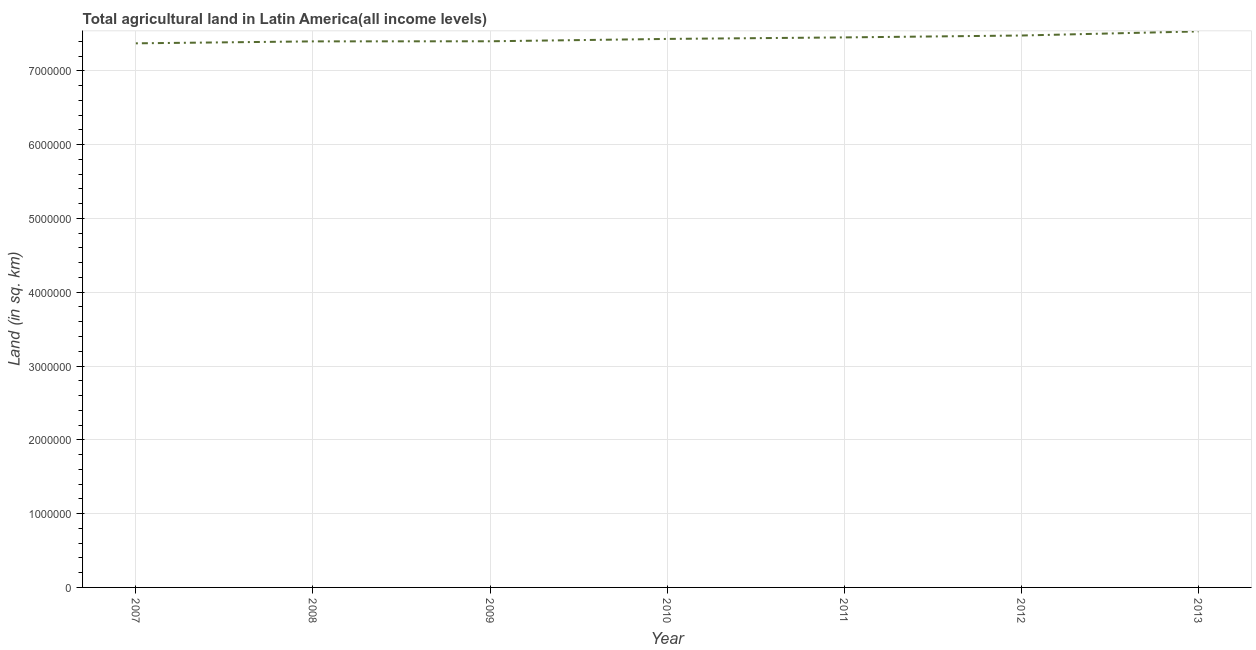What is the agricultural land in 2012?
Your response must be concise. 7.48e+06. Across all years, what is the maximum agricultural land?
Provide a succinct answer. 7.53e+06. Across all years, what is the minimum agricultural land?
Provide a succinct answer. 7.37e+06. In which year was the agricultural land maximum?
Your response must be concise. 2013. What is the sum of the agricultural land?
Offer a terse response. 5.21e+07. What is the difference between the agricultural land in 2010 and 2011?
Make the answer very short. -2.05e+04. What is the average agricultural land per year?
Provide a short and direct response. 7.44e+06. What is the median agricultural land?
Provide a short and direct response. 7.43e+06. In how many years, is the agricultural land greater than 4800000 sq. km?
Your answer should be very brief. 7. What is the ratio of the agricultural land in 2008 to that in 2013?
Keep it short and to the point. 0.98. Is the agricultural land in 2008 less than that in 2011?
Ensure brevity in your answer.  Yes. Is the difference between the agricultural land in 2011 and 2012 greater than the difference between any two years?
Offer a terse response. No. What is the difference between the highest and the second highest agricultural land?
Keep it short and to the point. 5.54e+04. Is the sum of the agricultural land in 2007 and 2011 greater than the maximum agricultural land across all years?
Provide a succinct answer. Yes. What is the difference between the highest and the lowest agricultural land?
Ensure brevity in your answer.  1.61e+05. How many lines are there?
Provide a short and direct response. 1. How many years are there in the graph?
Provide a short and direct response. 7. What is the difference between two consecutive major ticks on the Y-axis?
Your response must be concise. 1.00e+06. Are the values on the major ticks of Y-axis written in scientific E-notation?
Your response must be concise. No. What is the title of the graph?
Provide a short and direct response. Total agricultural land in Latin America(all income levels). What is the label or title of the X-axis?
Offer a very short reply. Year. What is the label or title of the Y-axis?
Your response must be concise. Land (in sq. km). What is the Land (in sq. km) in 2007?
Your answer should be very brief. 7.37e+06. What is the Land (in sq. km) in 2008?
Your answer should be compact. 7.40e+06. What is the Land (in sq. km) of 2009?
Offer a very short reply. 7.40e+06. What is the Land (in sq. km) of 2010?
Your response must be concise. 7.43e+06. What is the Land (in sq. km) of 2011?
Provide a succinct answer. 7.45e+06. What is the Land (in sq. km) in 2012?
Provide a short and direct response. 7.48e+06. What is the Land (in sq. km) of 2013?
Give a very brief answer. 7.53e+06. What is the difference between the Land (in sq. km) in 2007 and 2008?
Your answer should be compact. -2.65e+04. What is the difference between the Land (in sq. km) in 2007 and 2009?
Your answer should be very brief. -2.79e+04. What is the difference between the Land (in sq. km) in 2007 and 2010?
Provide a succinct answer. -5.97e+04. What is the difference between the Land (in sq. km) in 2007 and 2011?
Offer a terse response. -8.03e+04. What is the difference between the Land (in sq. km) in 2007 and 2012?
Provide a short and direct response. -1.06e+05. What is the difference between the Land (in sq. km) in 2007 and 2013?
Provide a short and direct response. -1.61e+05. What is the difference between the Land (in sq. km) in 2008 and 2009?
Offer a very short reply. -1397.7. What is the difference between the Land (in sq. km) in 2008 and 2010?
Your response must be concise. -3.33e+04. What is the difference between the Land (in sq. km) in 2008 and 2011?
Your answer should be very brief. -5.38e+04. What is the difference between the Land (in sq. km) in 2008 and 2012?
Provide a short and direct response. -7.95e+04. What is the difference between the Land (in sq. km) in 2008 and 2013?
Offer a terse response. -1.35e+05. What is the difference between the Land (in sq. km) in 2009 and 2010?
Your response must be concise. -3.19e+04. What is the difference between the Land (in sq. km) in 2009 and 2011?
Ensure brevity in your answer.  -5.24e+04. What is the difference between the Land (in sq. km) in 2009 and 2012?
Offer a very short reply. -7.81e+04. What is the difference between the Land (in sq. km) in 2009 and 2013?
Make the answer very short. -1.33e+05. What is the difference between the Land (in sq. km) in 2010 and 2011?
Keep it short and to the point. -2.05e+04. What is the difference between the Land (in sq. km) in 2010 and 2012?
Your answer should be compact. -4.62e+04. What is the difference between the Land (in sq. km) in 2010 and 2013?
Provide a short and direct response. -1.02e+05. What is the difference between the Land (in sq. km) in 2011 and 2012?
Make the answer very short. -2.57e+04. What is the difference between the Land (in sq. km) in 2011 and 2013?
Make the answer very short. -8.11e+04. What is the difference between the Land (in sq. km) in 2012 and 2013?
Offer a very short reply. -5.54e+04. What is the ratio of the Land (in sq. km) in 2007 to that in 2008?
Give a very brief answer. 1. What is the ratio of the Land (in sq. km) in 2007 to that in 2010?
Make the answer very short. 0.99. What is the ratio of the Land (in sq. km) in 2007 to that in 2011?
Your answer should be very brief. 0.99. What is the ratio of the Land (in sq. km) in 2008 to that in 2009?
Offer a terse response. 1. What is the ratio of the Land (in sq. km) in 2009 to that in 2011?
Ensure brevity in your answer.  0.99. What is the ratio of the Land (in sq. km) in 2009 to that in 2012?
Provide a short and direct response. 0.99. What is the ratio of the Land (in sq. km) in 2010 to that in 2011?
Your answer should be compact. 1. What is the ratio of the Land (in sq. km) in 2010 to that in 2012?
Keep it short and to the point. 0.99. What is the ratio of the Land (in sq. km) in 2010 to that in 2013?
Offer a terse response. 0.99. What is the ratio of the Land (in sq. km) in 2011 to that in 2012?
Provide a short and direct response. 1. What is the ratio of the Land (in sq. km) in 2011 to that in 2013?
Ensure brevity in your answer.  0.99. What is the ratio of the Land (in sq. km) in 2012 to that in 2013?
Give a very brief answer. 0.99. 